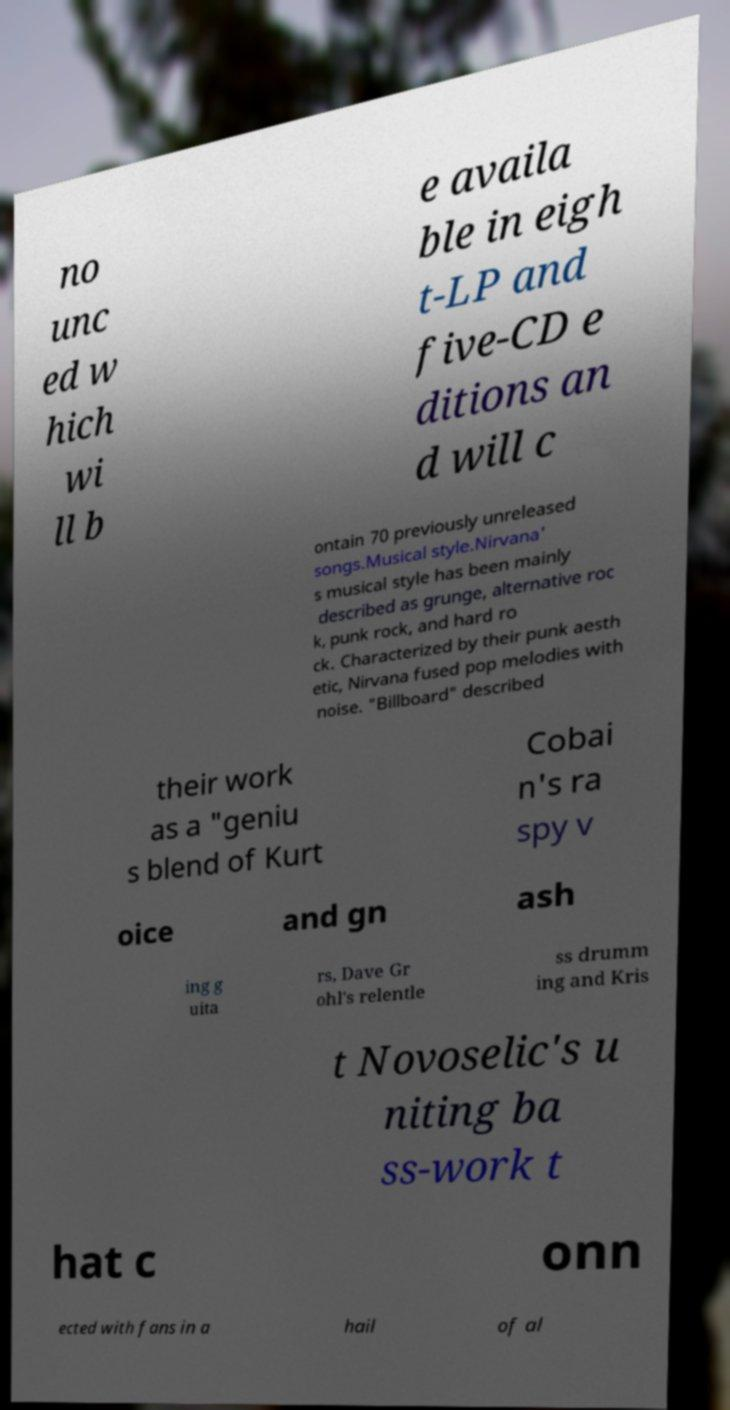For documentation purposes, I need the text within this image transcribed. Could you provide that? no unc ed w hich wi ll b e availa ble in eigh t-LP and five-CD e ditions an d will c ontain 70 previously unreleased songs.Musical style.Nirvana' s musical style has been mainly described as grunge, alternative roc k, punk rock, and hard ro ck. Characterized by their punk aesth etic, Nirvana fused pop melodies with noise. "Billboard" described their work as a "geniu s blend of Kurt Cobai n's ra spy v oice and gn ash ing g uita rs, Dave Gr ohl's relentle ss drumm ing and Kris t Novoselic's u niting ba ss-work t hat c onn ected with fans in a hail of al 